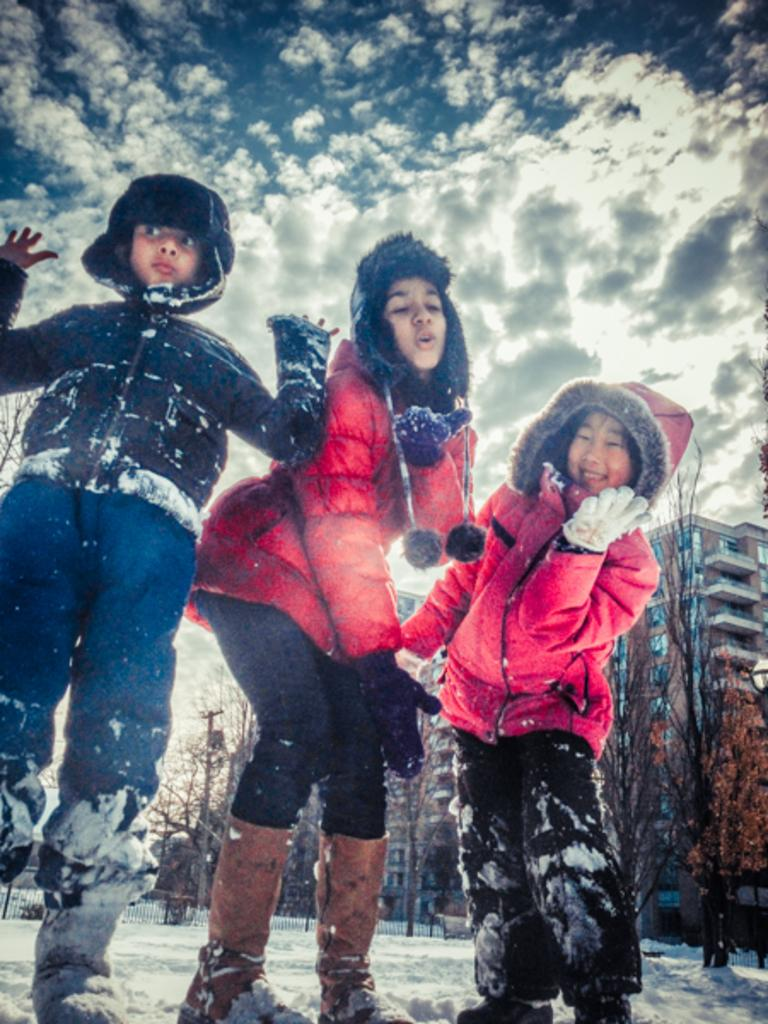How many people are visible in the image? There are three people standing in the front of the image. What is the weather like in the image? There is snow in the image, indicating a cold and likely wintery environment. What type of vegetation can be seen in the image? There are trees in the image. What type of structures are present in the image? There are buildings in the image. What is the purpose of the current pole in the image? The current pole is likely used for providing electricity to the area. What is visible in the sky in the image? The sky is visible in the image, and clouds are present. What type of throat is visible in the image? There is no throat visible in the image. What type of fork is being used to eat the snow in the image? There is no fork or eating of snow depicted in the image. 